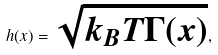<formula> <loc_0><loc_0><loc_500><loc_500>h ( x ) = \sqrt { k _ { B } T \Gamma ( x ) } ,</formula> 